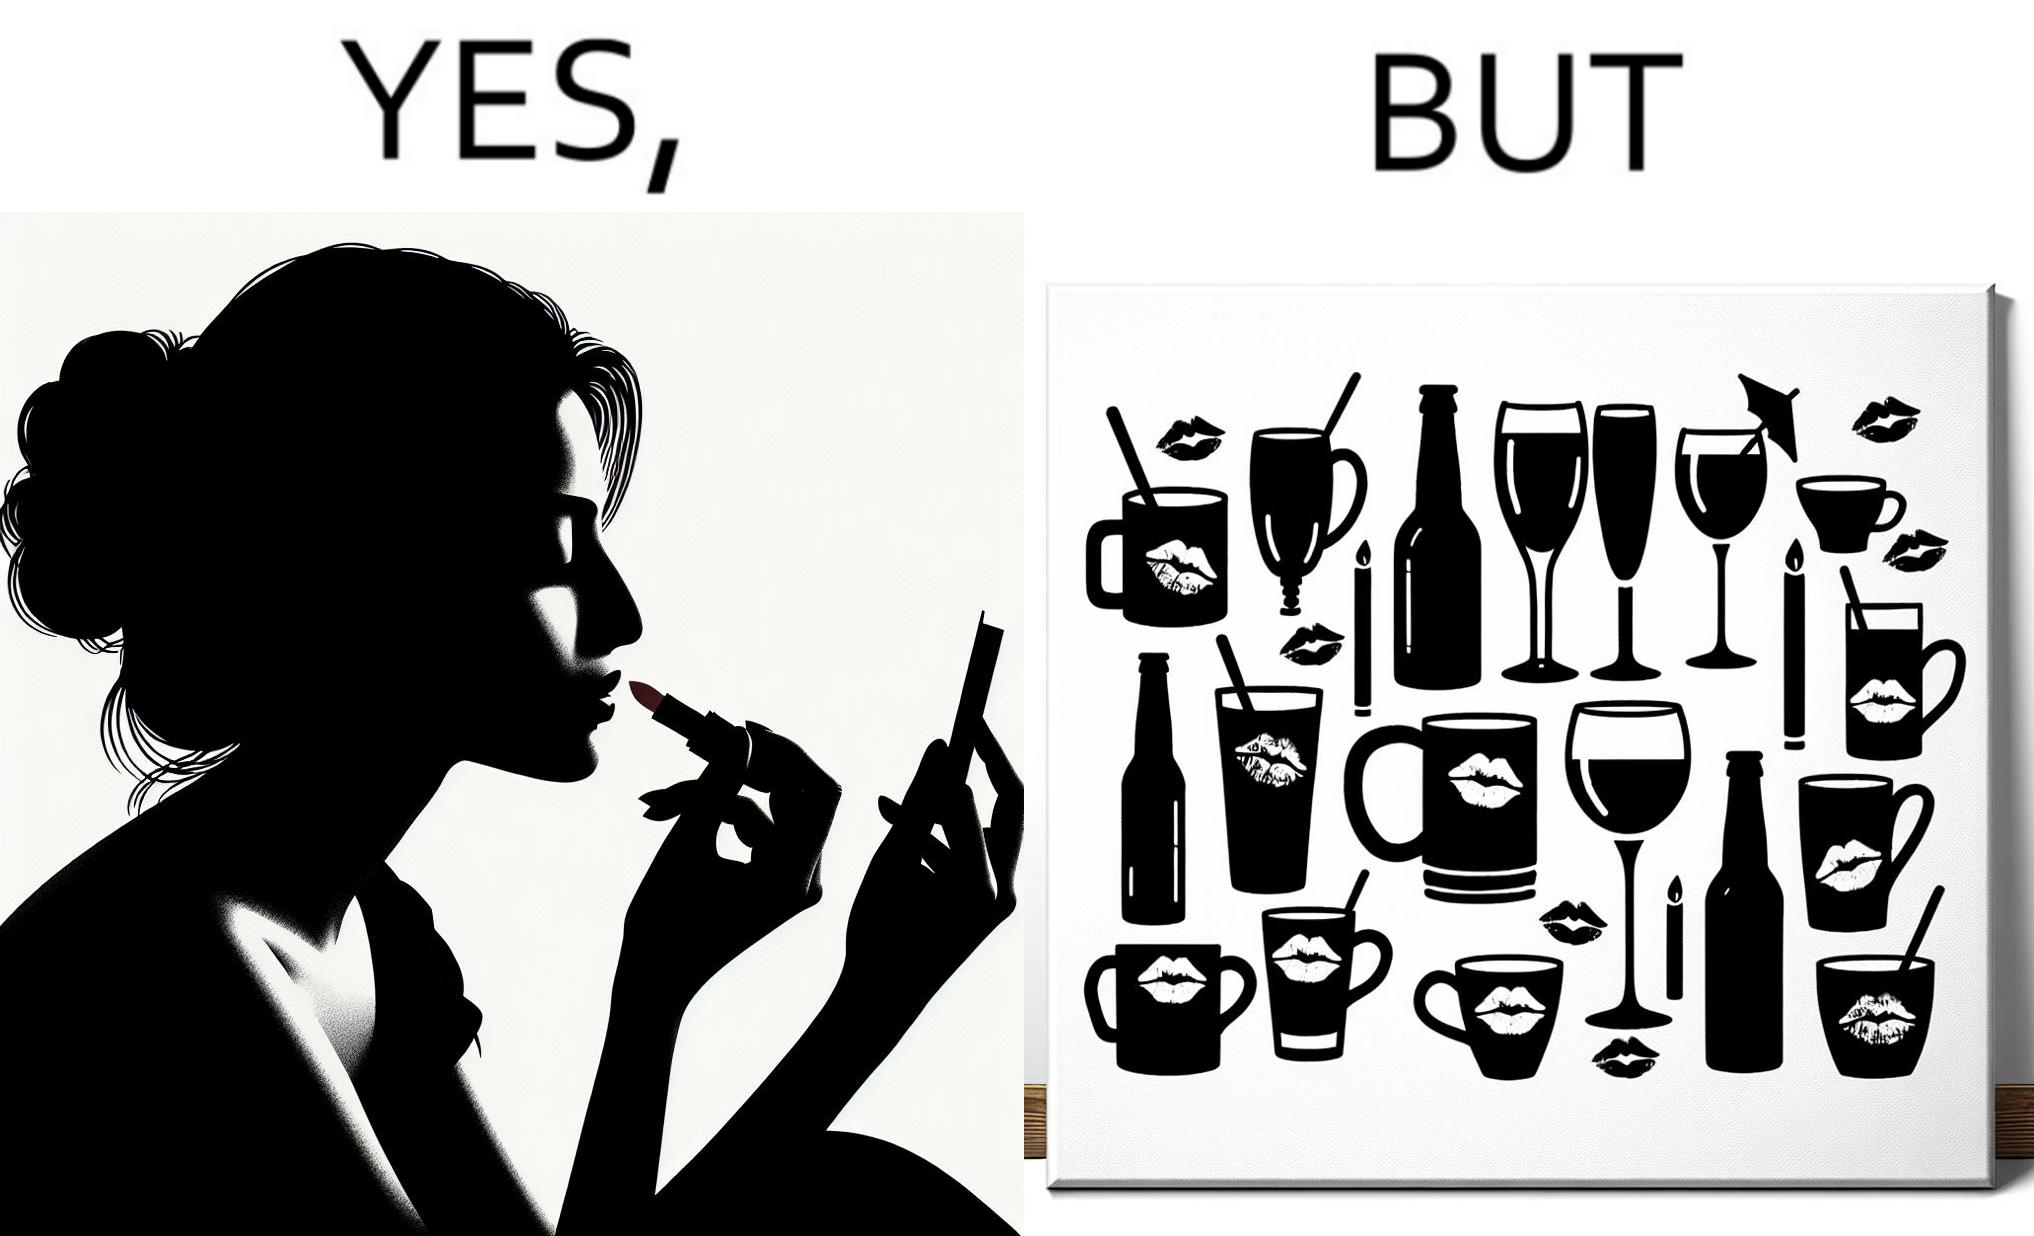Would you classify this image as satirical? Yes, this image is satirical. 